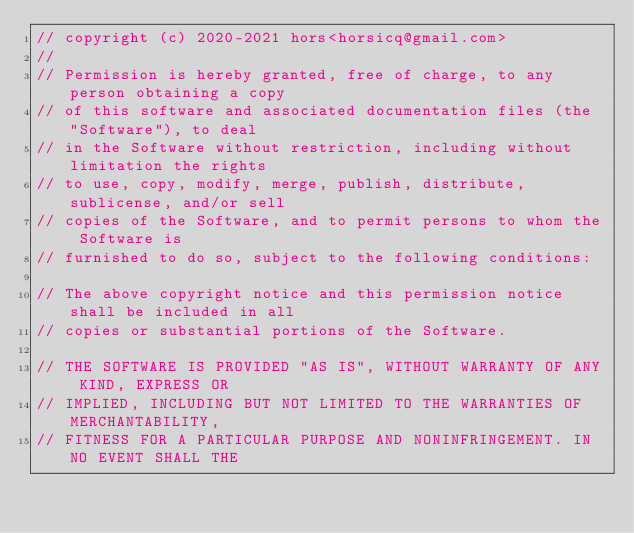Convert code to text. <code><loc_0><loc_0><loc_500><loc_500><_C++_>// copyright (c) 2020-2021 hors<horsicq@gmail.com>
//
// Permission is hereby granted, free of charge, to any person obtaining a copy
// of this software and associated documentation files (the "Software"), to deal
// in the Software without restriction, including without limitation the rights
// to use, copy, modify, merge, publish, distribute, sublicense, and/or sell
// copies of the Software, and to permit persons to whom the Software is
// furnished to do so, subject to the following conditions:

// The above copyright notice and this permission notice shall be included in all
// copies or substantial portions of the Software.

// THE SOFTWARE IS PROVIDED "AS IS", WITHOUT WARRANTY OF ANY KIND, EXPRESS OR
// IMPLIED, INCLUDING BUT NOT LIMITED TO THE WARRANTIES OF MERCHANTABILITY,
// FITNESS FOR A PARTICULAR PURPOSE AND NONINFRINGEMENT. IN NO EVENT SHALL THE</code> 